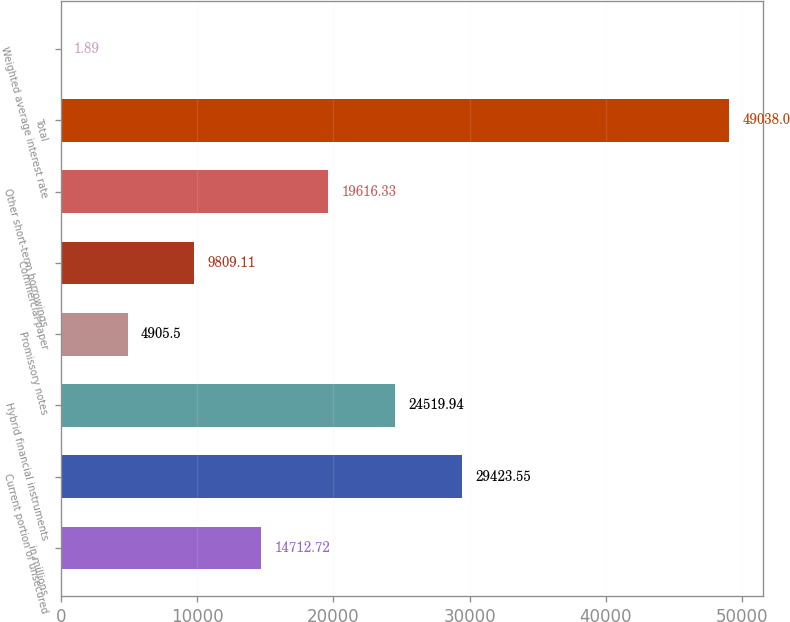Convert chart to OTSL. <chart><loc_0><loc_0><loc_500><loc_500><bar_chart><fcel>in millions<fcel>Current portion of unsecured<fcel>Hybrid financial instruments<fcel>Promissory notes<fcel>Commercial paper<fcel>Other short-term borrowings<fcel>Total<fcel>Weighted average interest rate<nl><fcel>14712.7<fcel>29423.5<fcel>24519.9<fcel>4905.5<fcel>9809.11<fcel>19616.3<fcel>49038<fcel>1.89<nl></chart> 